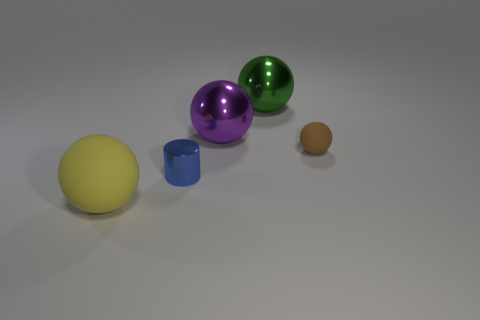There is a rubber ball that is behind the yellow rubber object; are there any green shiny things behind it?
Provide a succinct answer. Yes. Are there an equal number of cylinders that are left of the large rubber thing and red metallic cylinders?
Provide a succinct answer. Yes. What number of other objects are there of the same size as the brown rubber object?
Your answer should be very brief. 1. Is the large purple ball to the right of the small blue thing made of the same material as the large ball in front of the brown ball?
Your answer should be compact. No. What size is the matte object to the left of the matte object that is to the right of the yellow matte object?
Your response must be concise. Large. What is the shape of the big rubber thing?
Your response must be concise. Sphere. There is a big purple metal thing; what number of purple metallic objects are behind it?
Make the answer very short. 0. What number of yellow balls have the same material as the large yellow thing?
Keep it short and to the point. 0. Are the big sphere behind the purple metallic ball and the brown thing made of the same material?
Keep it short and to the point. No. Is there a small yellow shiny object?
Your response must be concise. No. 